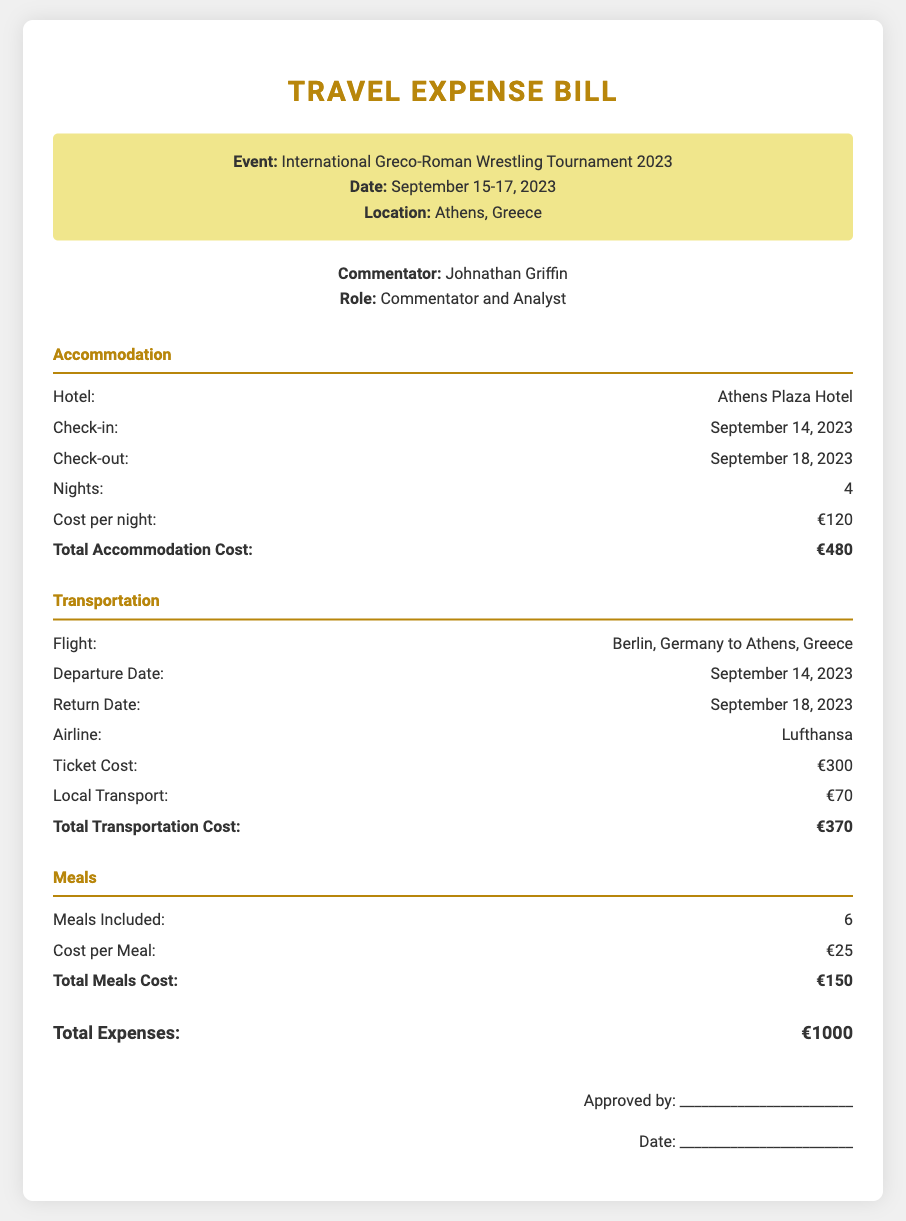What is the total accommodation cost? The total accommodation cost is calculated as the number of nights (4) multiplied by the cost per night (€120), which equals €480.
Answer: €480 What is the location of the event? The document specifies the location of the event as Athens, Greece.
Answer: Athens, Greece Who is the commentator? The document lists the commentator as Johnathan Griffin.
Answer: Johnathan Griffin What is the ticket cost for the flight? The ticket cost for the flight to Athens is specified as €300.
Answer: €300 How many meals were included? The document states that a total of 6 meals were included.
Answer: 6 What is the total transportation cost? The total transportation cost is the sum of the ticket cost (€300) and the local transport cost (€70), which totals €370.
Answer: €370 What is the check-in date for accommodation? The check-in date for the accommodation is September 14, 2023.
Answer: September 14, 2023 How many nights did the commentator stay? The document indicates that the commentator stayed for 4 nights.
Answer: 4 What is the total expenses for the trip? The total expenses are the sum of accommodation (€480), transportation (€370), and meals (€150), totaling €1000.
Answer: €1000 